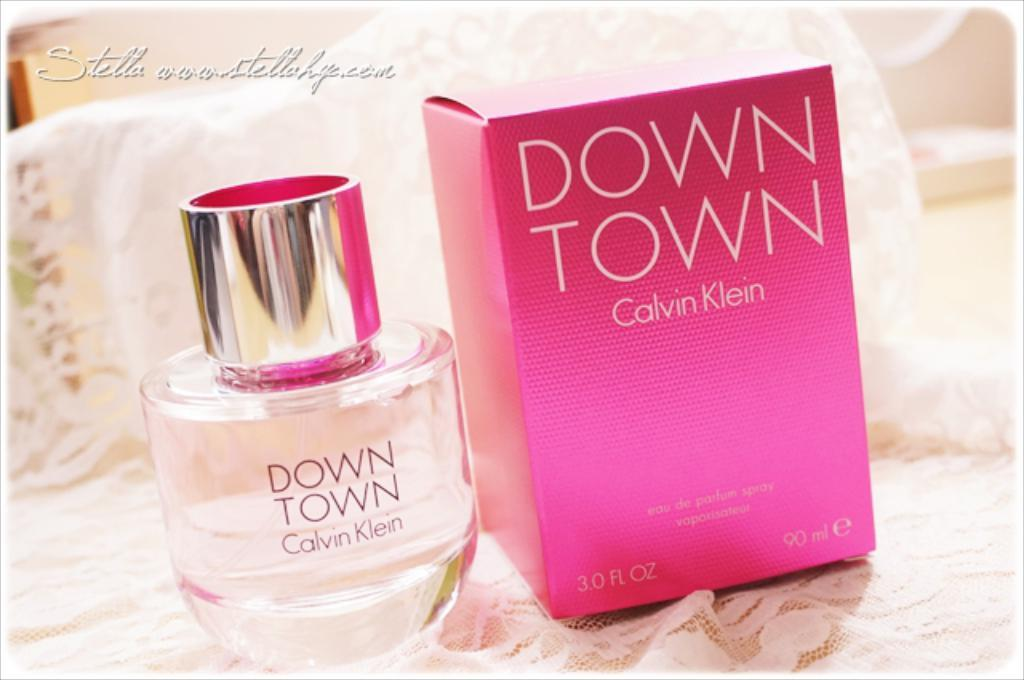Provide a one-sentence caption for the provided image. A bottle of Down Town by Calvin Klein next to the box it came in. 